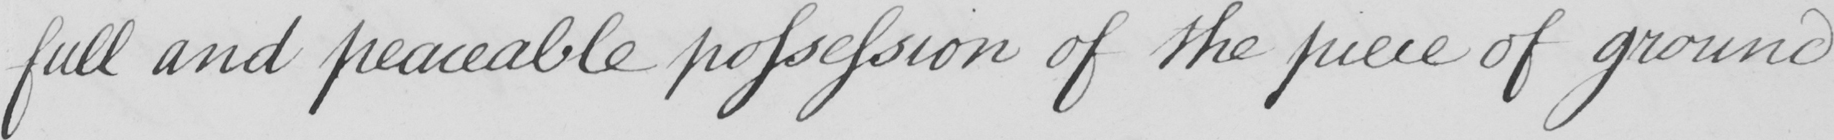Please provide the text content of this handwritten line. full and peaceable possession of the piece of ground 